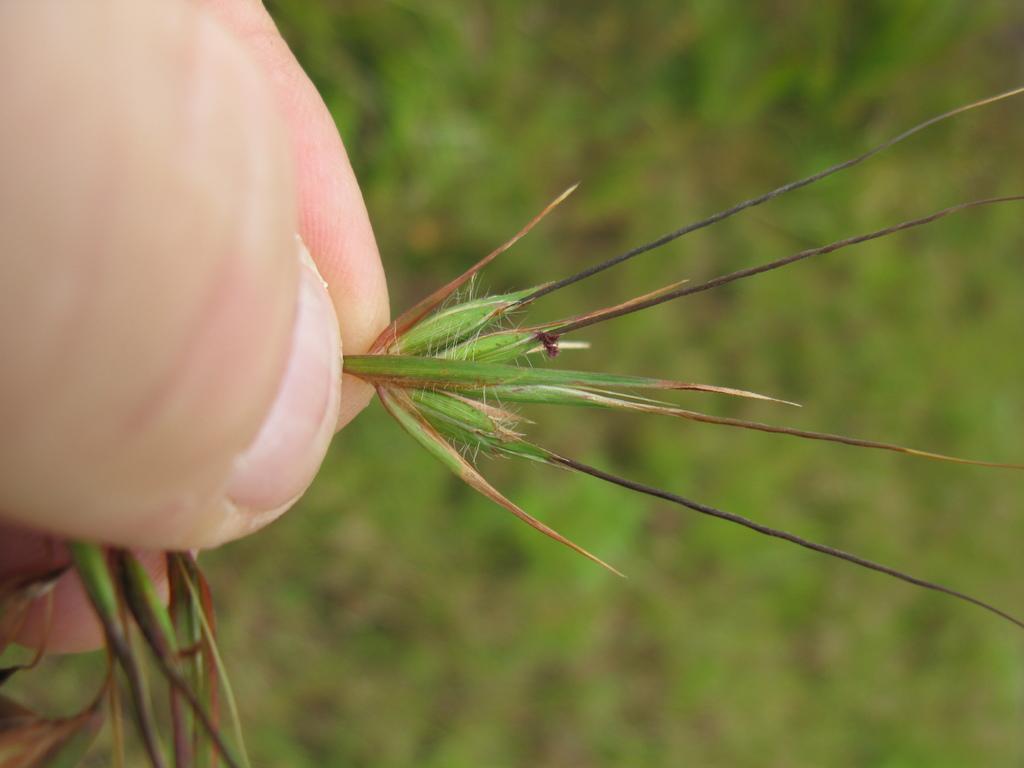How would you summarize this image in a sentence or two? In this image we can see a person's hand holding a plant and the background image is blurred. 